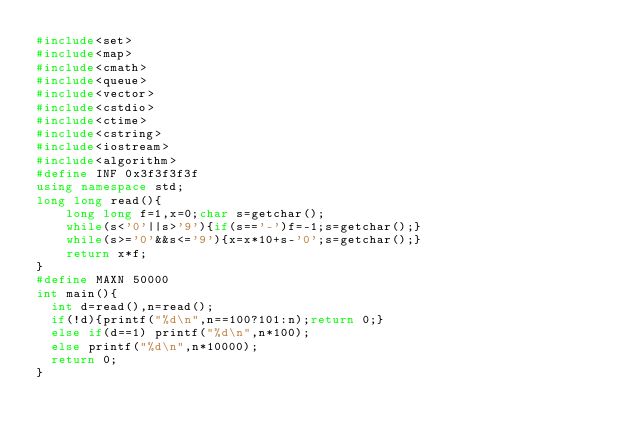Convert code to text. <code><loc_0><loc_0><loc_500><loc_500><_C++_>#include<set> 
#include<map>
#include<cmath>    
#include<queue>    
#include<vector>    
#include<cstdio>    
#include<ctime>   
#include<cstring>    
#include<iostream>    
#include<algorithm>    
#define INF 0x3f3f3f3f
using namespace std;
long long read(){
    long long f=1,x=0;char s=getchar();   
    while(s<'0'||s>'9'){if(s=='-')f=-1;s=getchar();}  
    while(s>='0'&&s<='9'){x=x*10+s-'0';s=getchar();}
    return x*f;
}
#define MAXN 50000
int main(){
	int d=read(),n=read();
	if(!d){printf("%d\n",n==100?101:n);return 0;}
	else if(d==1) printf("%d\n",n*100);
	else printf("%d\n",n*10000);
	return 0;
}  </code> 